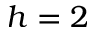<formula> <loc_0><loc_0><loc_500><loc_500>h = 2</formula> 